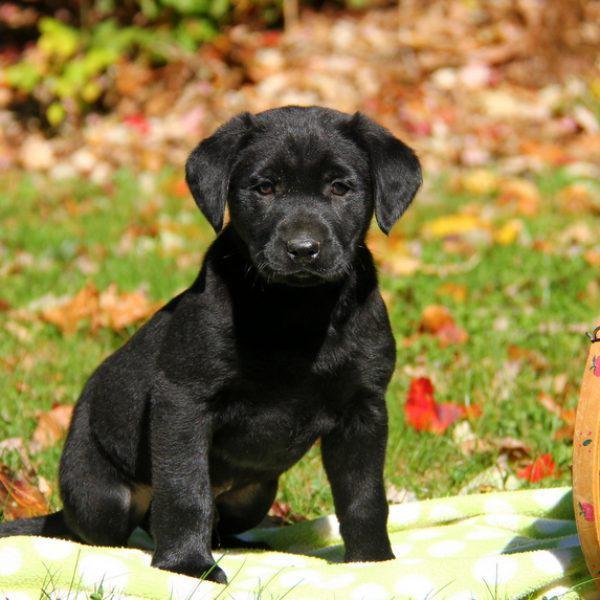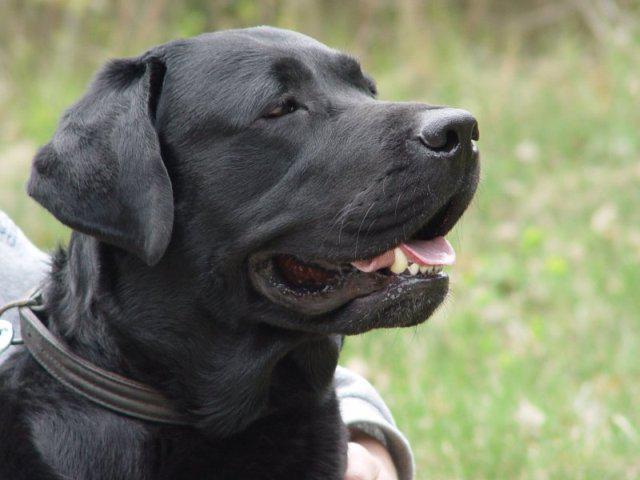The first image is the image on the left, the second image is the image on the right. Analyze the images presented: Is the assertion "In one image, one adult dog has its mouth open showing its tongue and is wearing a collar, while a second image shows a sitting puppy of the same breed." valid? Answer yes or no. Yes. The first image is the image on the left, the second image is the image on the right. Evaluate the accuracy of this statement regarding the images: "Left image shows a black puppy sitting upright outdoors, but not sitting directly on grass.". Is it true? Answer yes or no. Yes. 